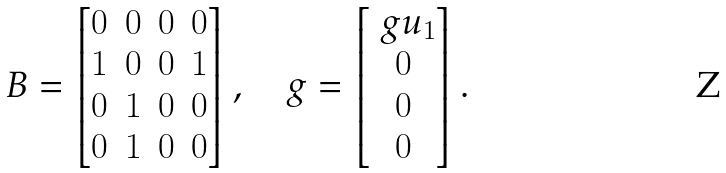<formula> <loc_0><loc_0><loc_500><loc_500>\ B = \begin{bmatrix} 0 & 0 & 0 & 0 \\ 1 & 0 & 0 & 1 \\ 0 & 1 & 0 & 0 \\ 0 & 1 & 0 & 0 \\ \end{bmatrix} , \quad g = \begin{bmatrix} \ g u _ { 1 } \\ 0 \\ 0 \\ 0 \end{bmatrix} .</formula> 